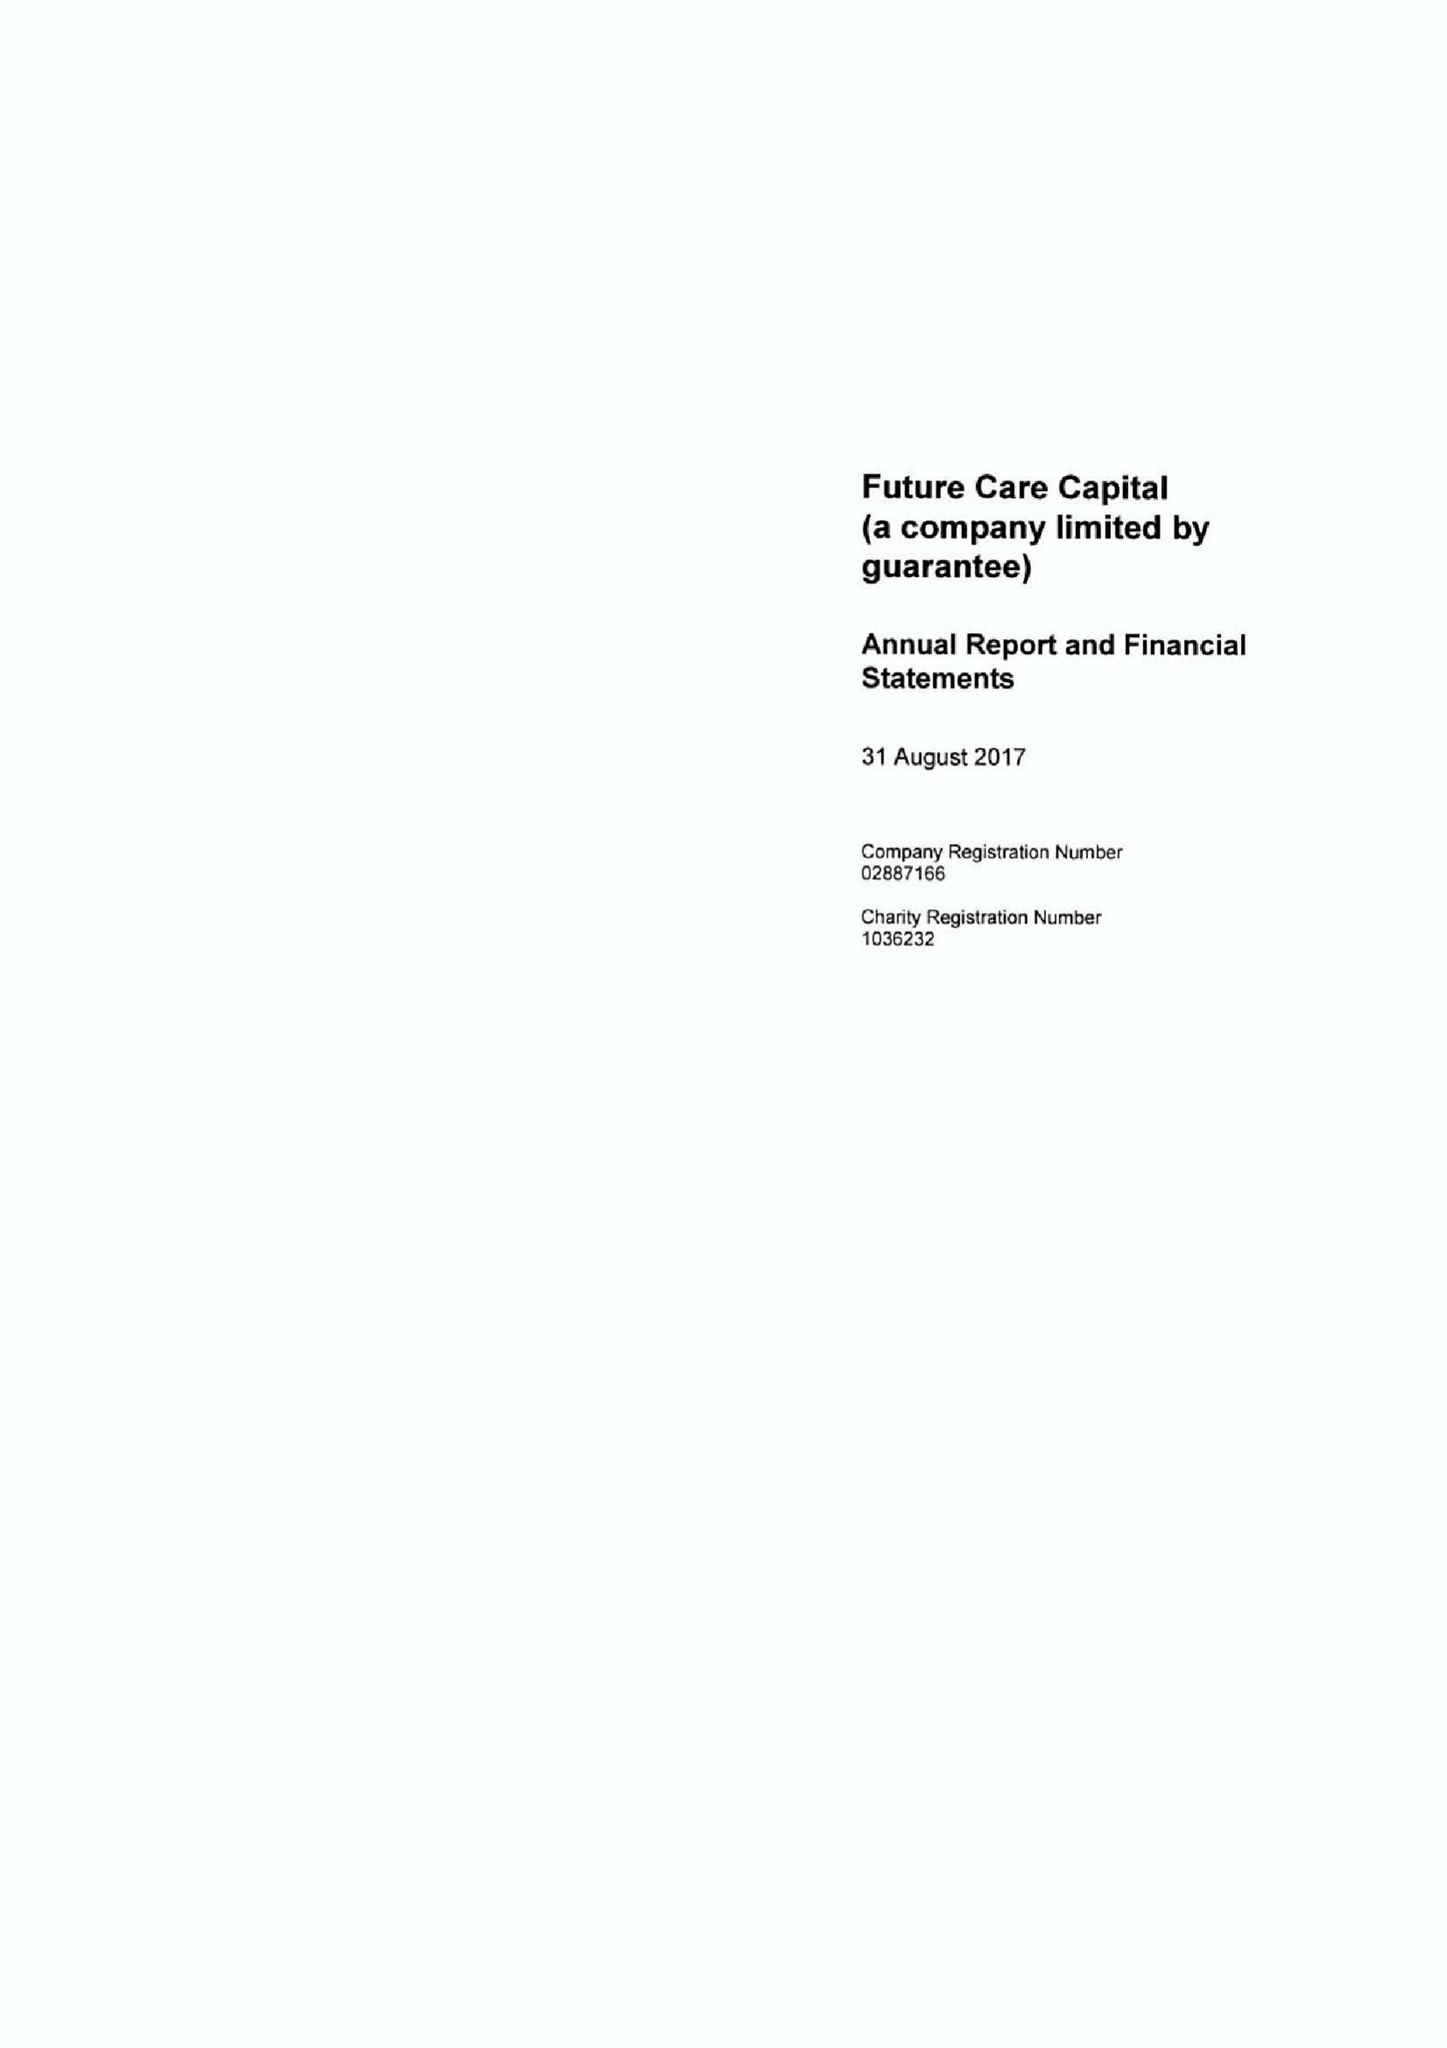What is the value for the spending_annually_in_british_pounds?
Answer the question using a single word or phrase. 937000.00 